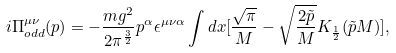Convert formula to latex. <formula><loc_0><loc_0><loc_500><loc_500>i \Pi ^ { \mu \nu } _ { o d d } ( p ) = - \frac { m g ^ { 2 } } { 2 \pi ^ { \frac { 3 } { 2 } } } p ^ { \alpha } \epsilon ^ { \mu \nu \alpha } \int d x [ \frac { \sqrt { \pi } } { M } - \sqrt { \frac { 2 \tilde { p } } { M } } { K } _ { \frac { 1 } { 2 } } ( \tilde { p } M ) ] ,</formula> 